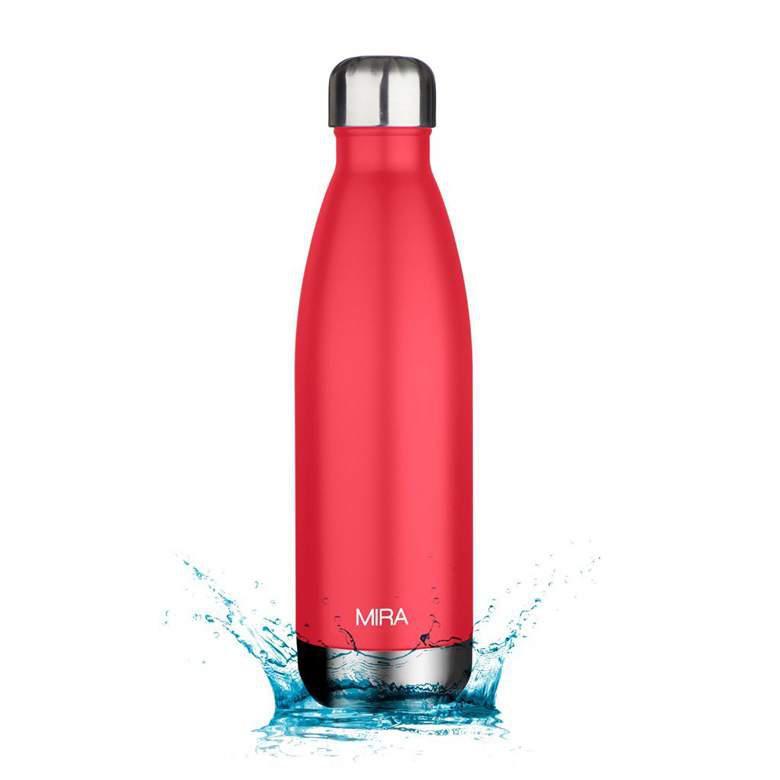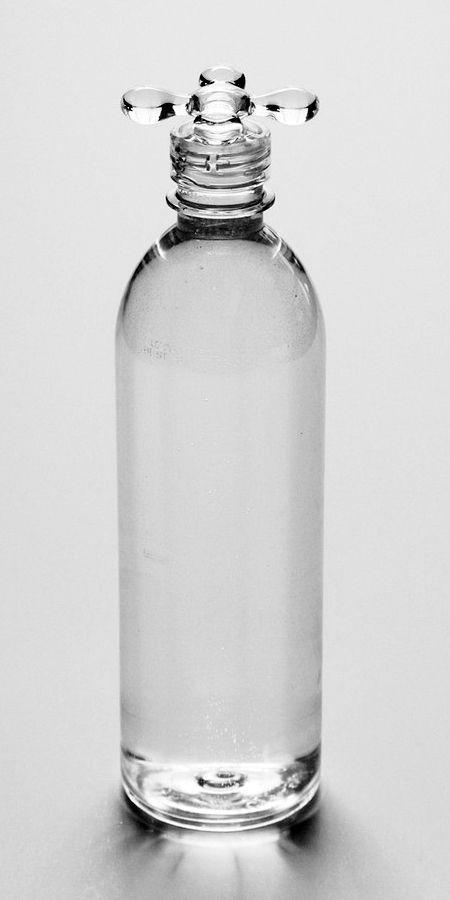The first image is the image on the left, the second image is the image on the right. For the images shown, is this caption "There are more than three bottles." true? Answer yes or no. No. The first image is the image on the left, the second image is the image on the right. Given the left and right images, does the statement "An image includes a clear water bottle with exactly three ribbed bands around its upper midsection." hold true? Answer yes or no. No. 